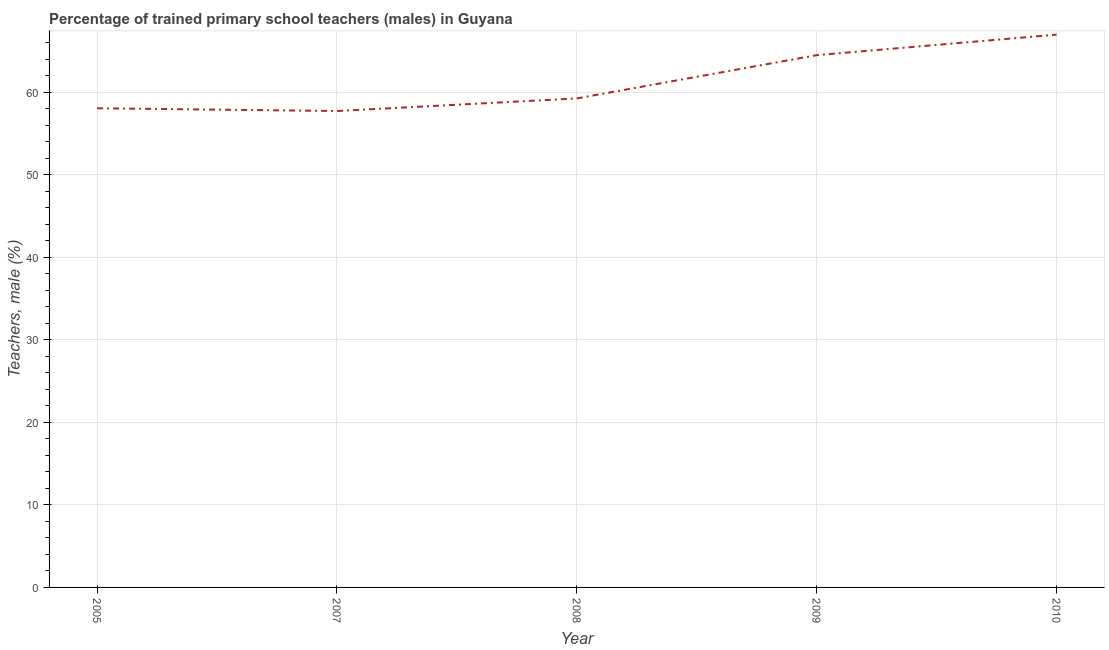What is the percentage of trained male teachers in 2009?
Your answer should be very brief. 64.47. Across all years, what is the maximum percentage of trained male teachers?
Make the answer very short. 66.96. Across all years, what is the minimum percentage of trained male teachers?
Offer a very short reply. 57.71. In which year was the percentage of trained male teachers maximum?
Give a very brief answer. 2010. In which year was the percentage of trained male teachers minimum?
Provide a succinct answer. 2007. What is the sum of the percentage of trained male teachers?
Make the answer very short. 306.4. What is the difference between the percentage of trained male teachers in 2008 and 2010?
Your answer should be compact. -7.73. What is the average percentage of trained male teachers per year?
Give a very brief answer. 61.28. What is the median percentage of trained male teachers?
Your answer should be compact. 59.23. In how many years, is the percentage of trained male teachers greater than 38 %?
Ensure brevity in your answer.  5. What is the ratio of the percentage of trained male teachers in 2008 to that in 2010?
Offer a terse response. 0.88. What is the difference between the highest and the second highest percentage of trained male teachers?
Provide a succinct answer. 2.49. Is the sum of the percentage of trained male teachers in 2007 and 2009 greater than the maximum percentage of trained male teachers across all years?
Your response must be concise. Yes. What is the difference between the highest and the lowest percentage of trained male teachers?
Give a very brief answer. 9.25. Does the percentage of trained male teachers monotonically increase over the years?
Give a very brief answer. No. How many lines are there?
Make the answer very short. 1. What is the difference between two consecutive major ticks on the Y-axis?
Offer a very short reply. 10. Does the graph contain any zero values?
Your answer should be compact. No. Does the graph contain grids?
Provide a succinct answer. Yes. What is the title of the graph?
Ensure brevity in your answer.  Percentage of trained primary school teachers (males) in Guyana. What is the label or title of the Y-axis?
Offer a terse response. Teachers, male (%). What is the Teachers, male (%) of 2005?
Offer a terse response. 58.04. What is the Teachers, male (%) in 2007?
Your answer should be very brief. 57.71. What is the Teachers, male (%) of 2008?
Your answer should be compact. 59.23. What is the Teachers, male (%) of 2009?
Offer a very short reply. 64.47. What is the Teachers, male (%) in 2010?
Your answer should be compact. 66.96. What is the difference between the Teachers, male (%) in 2005 and 2007?
Make the answer very short. 0.33. What is the difference between the Teachers, male (%) in 2005 and 2008?
Provide a succinct answer. -1.19. What is the difference between the Teachers, male (%) in 2005 and 2009?
Give a very brief answer. -6.43. What is the difference between the Teachers, male (%) in 2005 and 2010?
Provide a short and direct response. -8.92. What is the difference between the Teachers, male (%) in 2007 and 2008?
Your answer should be very brief. -1.52. What is the difference between the Teachers, male (%) in 2007 and 2009?
Provide a succinct answer. -6.76. What is the difference between the Teachers, male (%) in 2007 and 2010?
Your answer should be compact. -9.25. What is the difference between the Teachers, male (%) in 2008 and 2009?
Your response must be concise. -5.24. What is the difference between the Teachers, male (%) in 2008 and 2010?
Ensure brevity in your answer.  -7.73. What is the difference between the Teachers, male (%) in 2009 and 2010?
Offer a terse response. -2.49. What is the ratio of the Teachers, male (%) in 2005 to that in 2010?
Your response must be concise. 0.87. What is the ratio of the Teachers, male (%) in 2007 to that in 2009?
Your answer should be very brief. 0.9. What is the ratio of the Teachers, male (%) in 2007 to that in 2010?
Your answer should be very brief. 0.86. What is the ratio of the Teachers, male (%) in 2008 to that in 2009?
Offer a terse response. 0.92. What is the ratio of the Teachers, male (%) in 2008 to that in 2010?
Provide a short and direct response. 0.89. What is the ratio of the Teachers, male (%) in 2009 to that in 2010?
Provide a short and direct response. 0.96. 